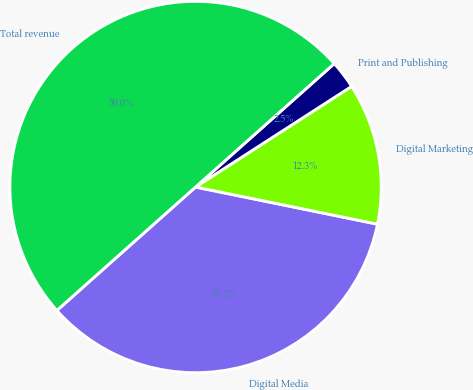Convert chart. <chart><loc_0><loc_0><loc_500><loc_500><pie_chart><fcel>Digital Media<fcel>Digital Marketing<fcel>Print and Publishing<fcel>Total revenue<nl><fcel>35.22%<fcel>12.32%<fcel>2.46%<fcel>50.0%<nl></chart> 